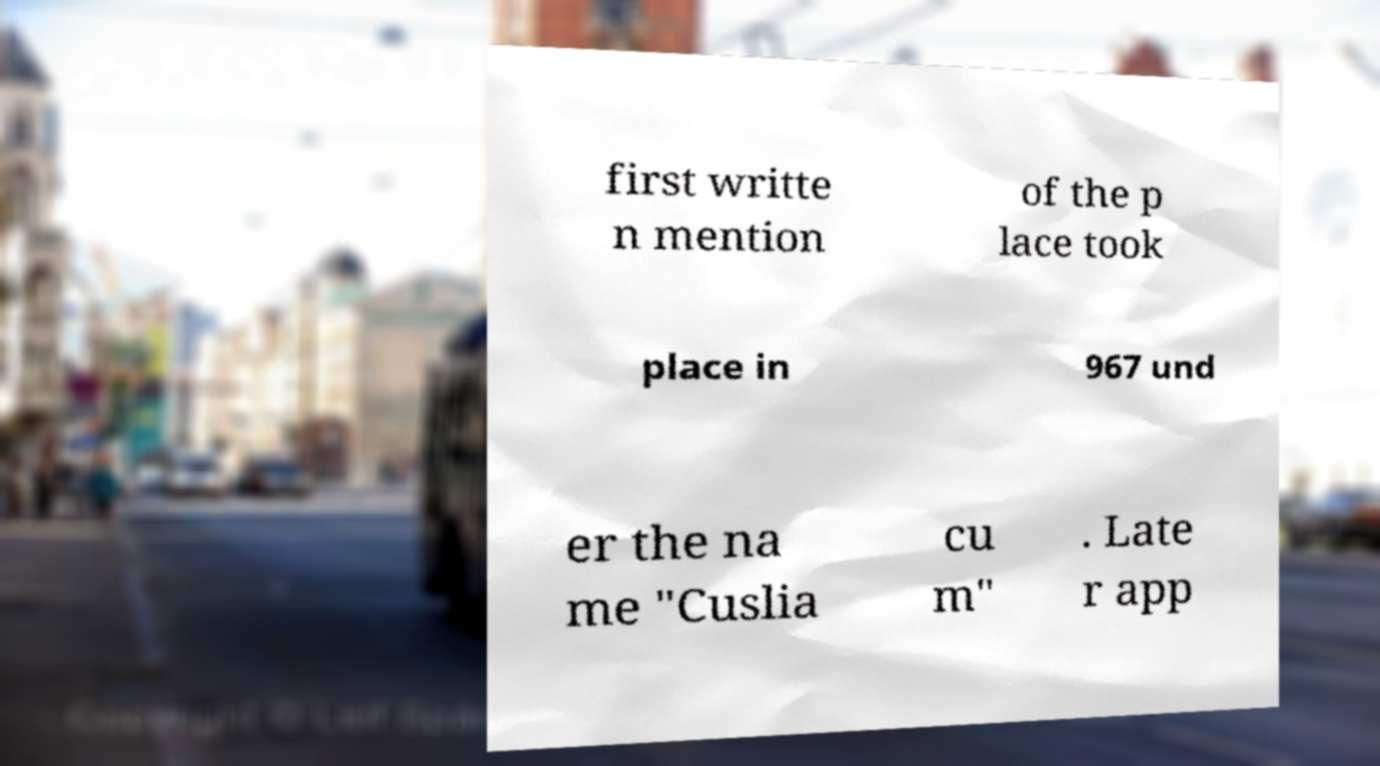Could you assist in decoding the text presented in this image and type it out clearly? first writte n mention of the p lace took place in 967 und er the na me "Cuslia cu m" . Late r app 